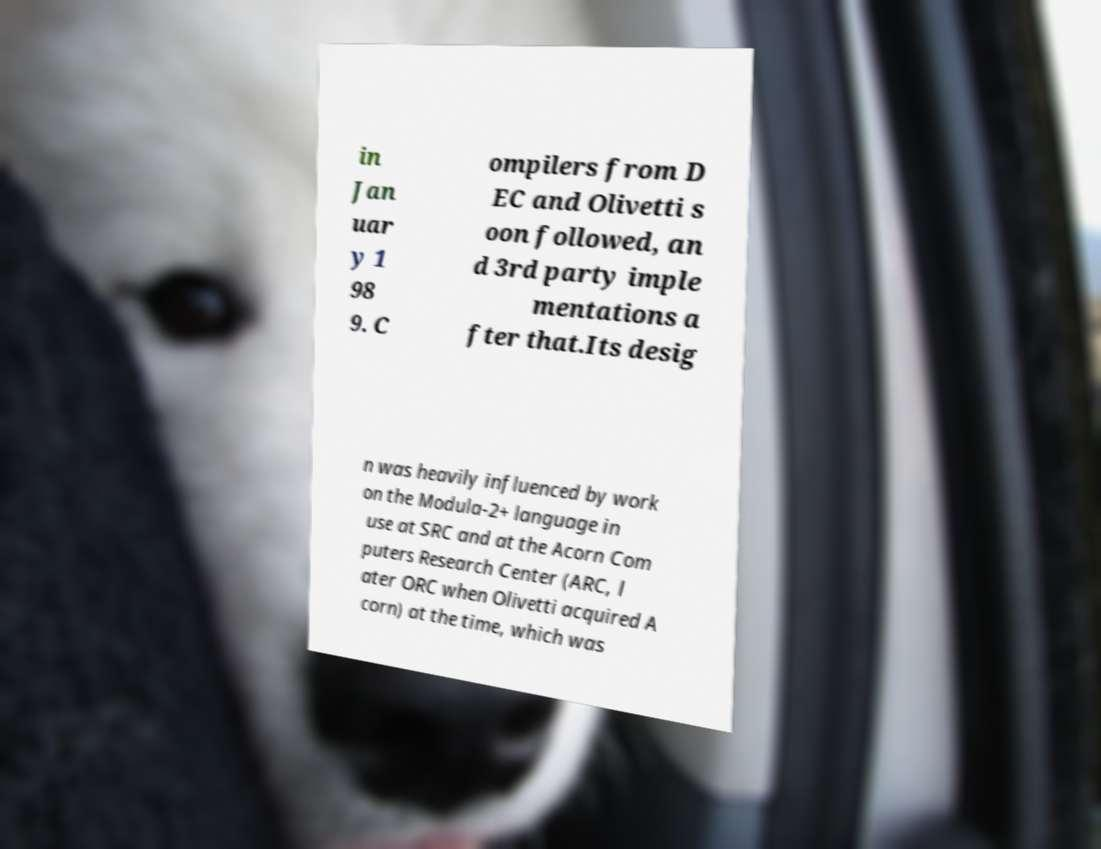For documentation purposes, I need the text within this image transcribed. Could you provide that? in Jan uar y 1 98 9. C ompilers from D EC and Olivetti s oon followed, an d 3rd party imple mentations a fter that.Its desig n was heavily influenced by work on the Modula-2+ language in use at SRC and at the Acorn Com puters Research Center (ARC, l ater ORC when Olivetti acquired A corn) at the time, which was 